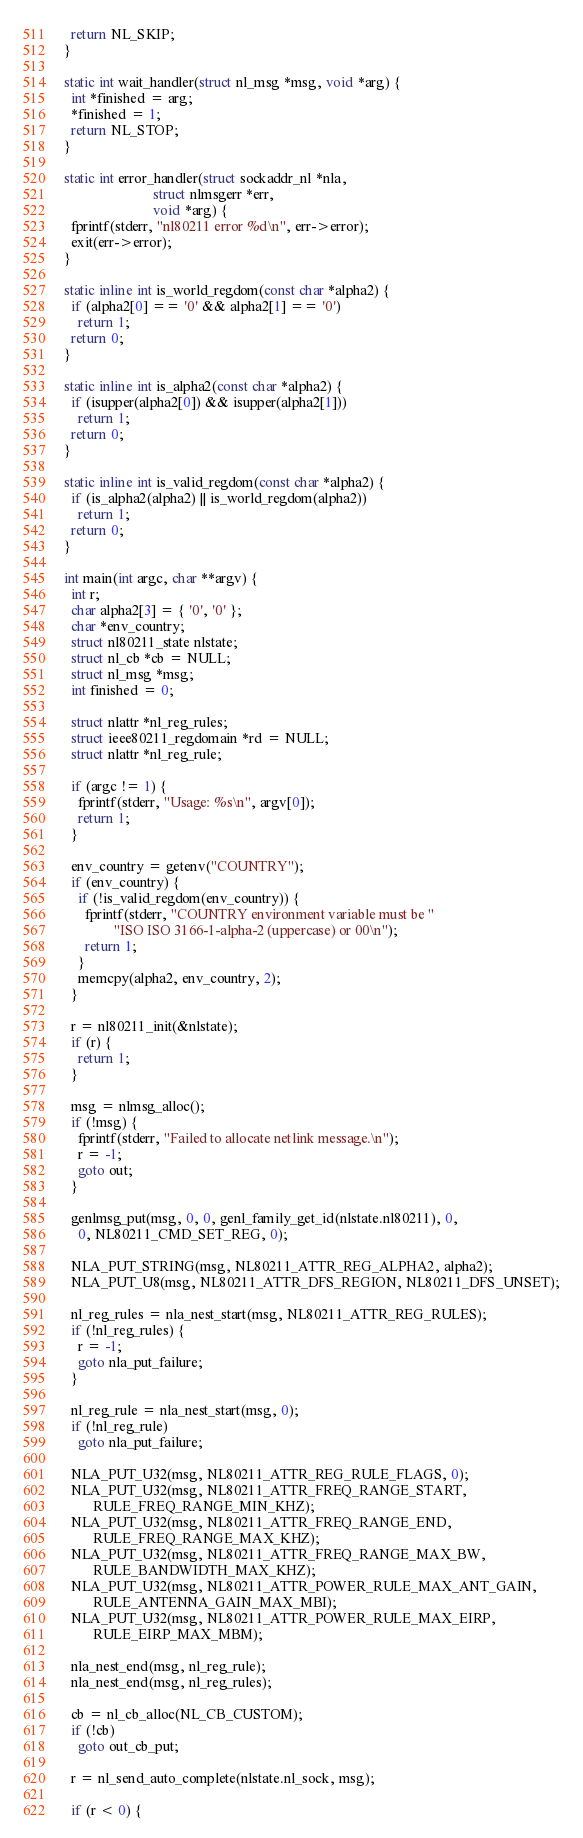Convert code to text. <code><loc_0><loc_0><loc_500><loc_500><_C_>  return NL_SKIP;
}

static int wait_handler(struct nl_msg *msg, void *arg) {
  int *finished = arg;
  *finished = 1;
  return NL_STOP;
}

static int error_handler(struct sockaddr_nl *nla,
                         struct nlmsgerr *err,
                         void *arg) {
  fprintf(stderr, "nl80211 error %d\n", err->error);
  exit(err->error);
}

static inline int is_world_regdom(const char *alpha2) {
  if (alpha2[0] == '0' && alpha2[1] == '0')
    return 1;
  return 0;
}

static inline int is_alpha2(const char *alpha2) {
  if (isupper(alpha2[0]) && isupper(alpha2[1]))
    return 1;
  return 0;
}

static inline int is_valid_regdom(const char *alpha2) {
  if (is_alpha2(alpha2) || is_world_regdom(alpha2))
    return 1;
  return 0;
}

int main(int argc, char **argv) {
  int r;
  char alpha2[3] = { '0', '0' };
  char *env_country;
  struct nl80211_state nlstate;
  struct nl_cb *cb = NULL;
  struct nl_msg *msg;
  int finished = 0;

  struct nlattr *nl_reg_rules;
  struct ieee80211_regdomain *rd = NULL;
  struct nlattr *nl_reg_rule;

  if (argc != 1) {
    fprintf(stderr, "Usage: %s\n", argv[0]);
    return 1;
  }

  env_country = getenv("COUNTRY");
  if (env_country) {
    if (!is_valid_regdom(env_country)) {
      fprintf(stderr, "COUNTRY environment variable must be "
              "ISO ISO 3166-1-alpha-2 (uppercase) or 00\n");
      return 1;
    }
    memcpy(alpha2, env_country, 2);
  }

  r = nl80211_init(&nlstate);
  if (r) {
    return 1;
  }

  msg = nlmsg_alloc();
  if (!msg) {
    fprintf(stderr, "Failed to allocate netlink message.\n");
    r = -1;
    goto out;
  }

  genlmsg_put(msg, 0, 0, genl_family_get_id(nlstate.nl80211), 0,
    0, NL80211_CMD_SET_REG, 0);

  NLA_PUT_STRING(msg, NL80211_ATTR_REG_ALPHA2, alpha2);
  NLA_PUT_U8(msg, NL80211_ATTR_DFS_REGION, NL80211_DFS_UNSET);

  nl_reg_rules = nla_nest_start(msg, NL80211_ATTR_REG_RULES);
  if (!nl_reg_rules) {
    r = -1;
    goto nla_put_failure;
  }

  nl_reg_rule = nla_nest_start(msg, 0);
  if (!nl_reg_rule)
    goto nla_put_failure;

  NLA_PUT_U32(msg, NL80211_ATTR_REG_RULE_FLAGS, 0);
  NLA_PUT_U32(msg, NL80211_ATTR_FREQ_RANGE_START,
        RULE_FREQ_RANGE_MIN_KHZ);
  NLA_PUT_U32(msg, NL80211_ATTR_FREQ_RANGE_END,
        RULE_FREQ_RANGE_MAX_KHZ);
  NLA_PUT_U32(msg, NL80211_ATTR_FREQ_RANGE_MAX_BW,
        RULE_BANDWIDTH_MAX_KHZ);
  NLA_PUT_U32(msg, NL80211_ATTR_POWER_RULE_MAX_ANT_GAIN,
        RULE_ANTENNA_GAIN_MAX_MBI);
  NLA_PUT_U32(msg, NL80211_ATTR_POWER_RULE_MAX_EIRP,
        RULE_EIRP_MAX_MBM);

  nla_nest_end(msg, nl_reg_rule);
  nla_nest_end(msg, nl_reg_rules);

  cb = nl_cb_alloc(NL_CB_CUSTOM);
  if (!cb)
    goto out_cb_put;

  r = nl_send_auto_complete(nlstate.nl_sock, msg);

  if (r < 0) {</code> 